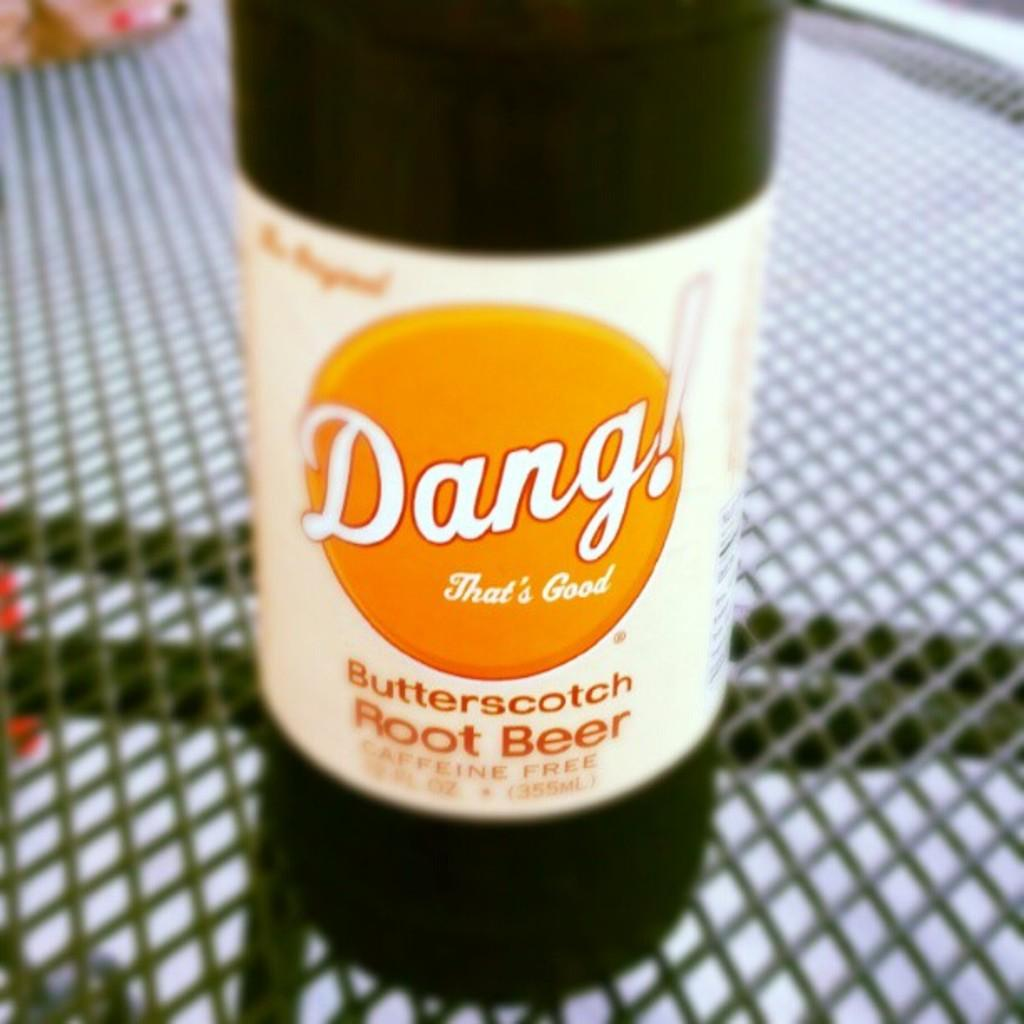Provide a one-sentence caption for the provided image. A bottle of butterscotch root beer has a label reading Dang! That's Good. 